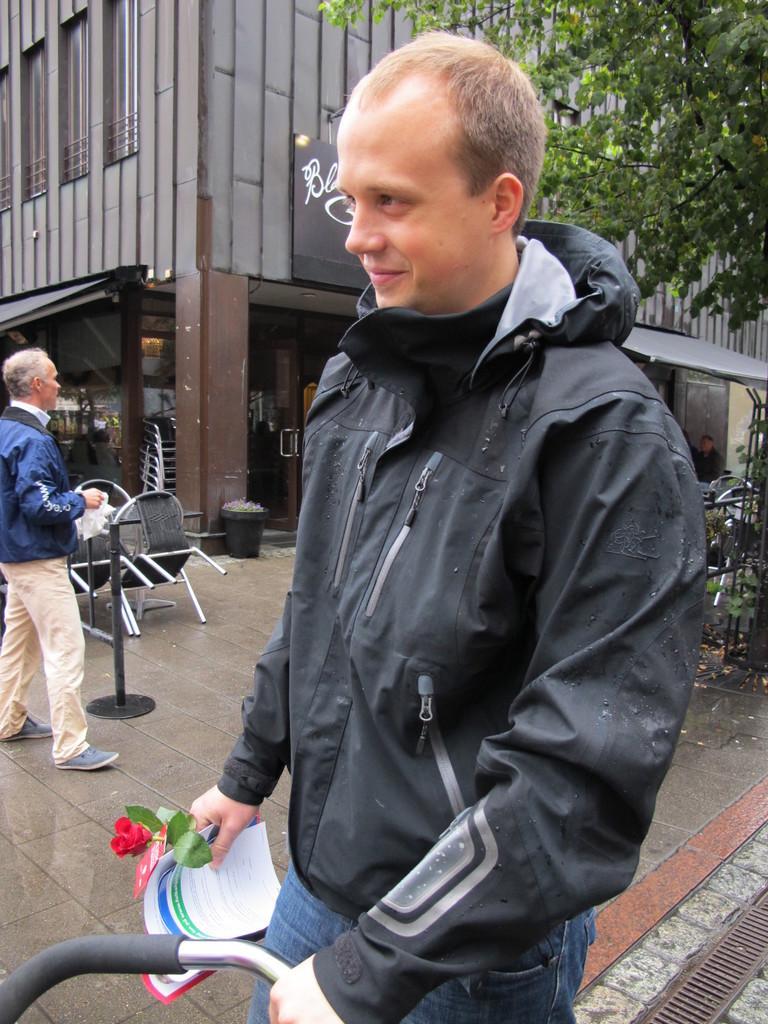In one or two sentences, can you explain what this image depicts? In this image in the foreground there is one man standing and he is holding some papers and flower. In the background there is another man, building, trees, dustbin, chairs and at the bottom there is walkway. 